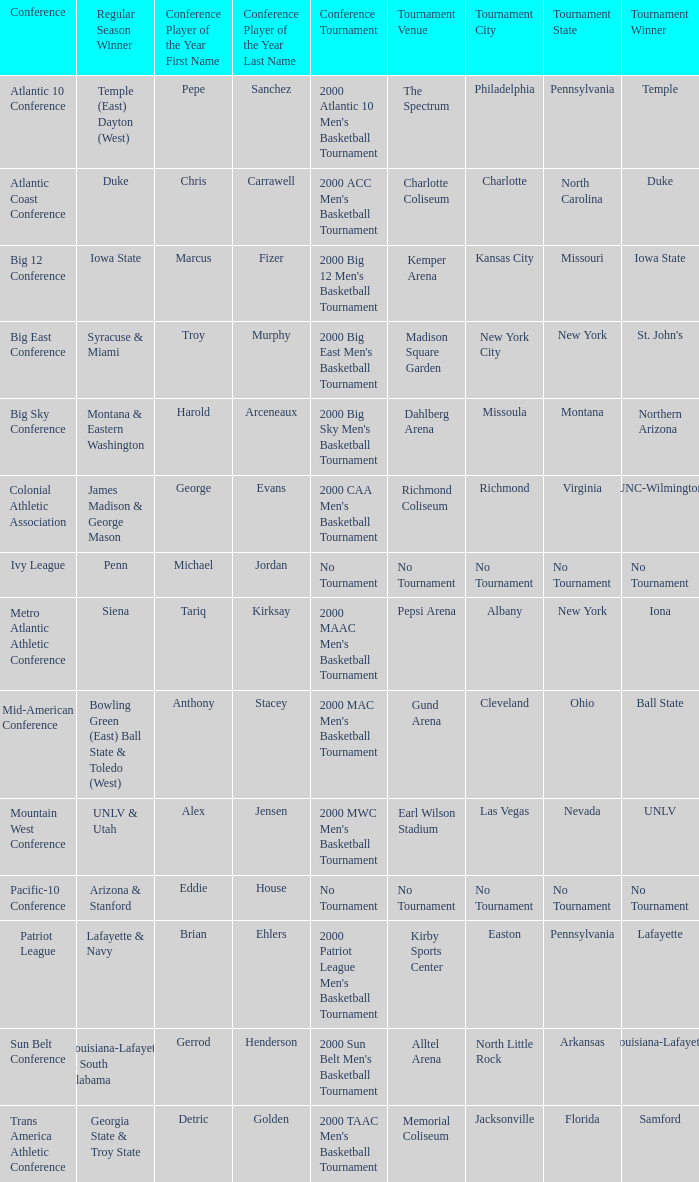What is the number of players of the year in the mountain west conference? 1.0. 